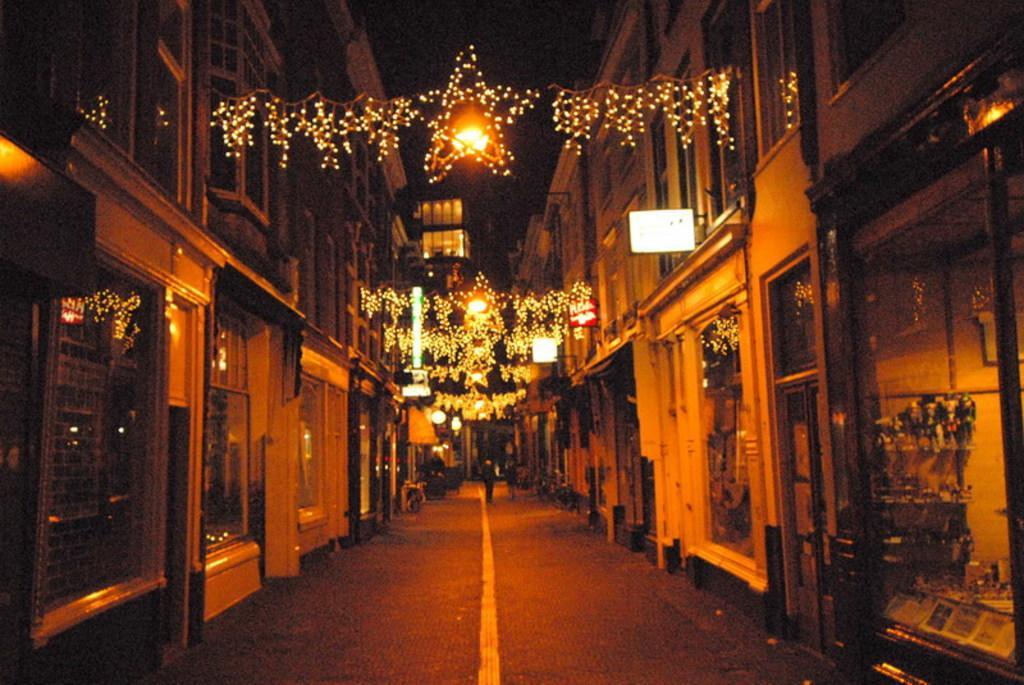Please provide a concise description of this image. In this image there is a road, on that road two persons are walking, on either side of the road there are buildings, on the top there is lighting. 